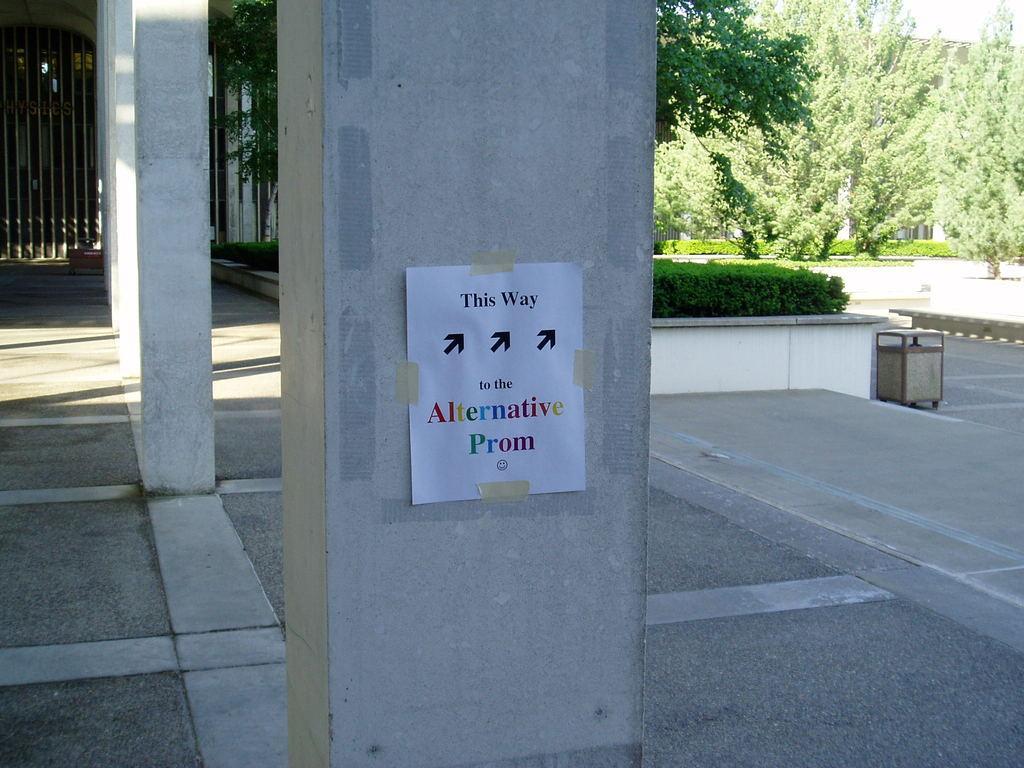How would you summarize this image in a sentence or two? In this image, we can see some pillars, trees, plants, poles. We can see the ground with some objects. We can also see the sky. We can see a poster with some text. We can also see some grass. 